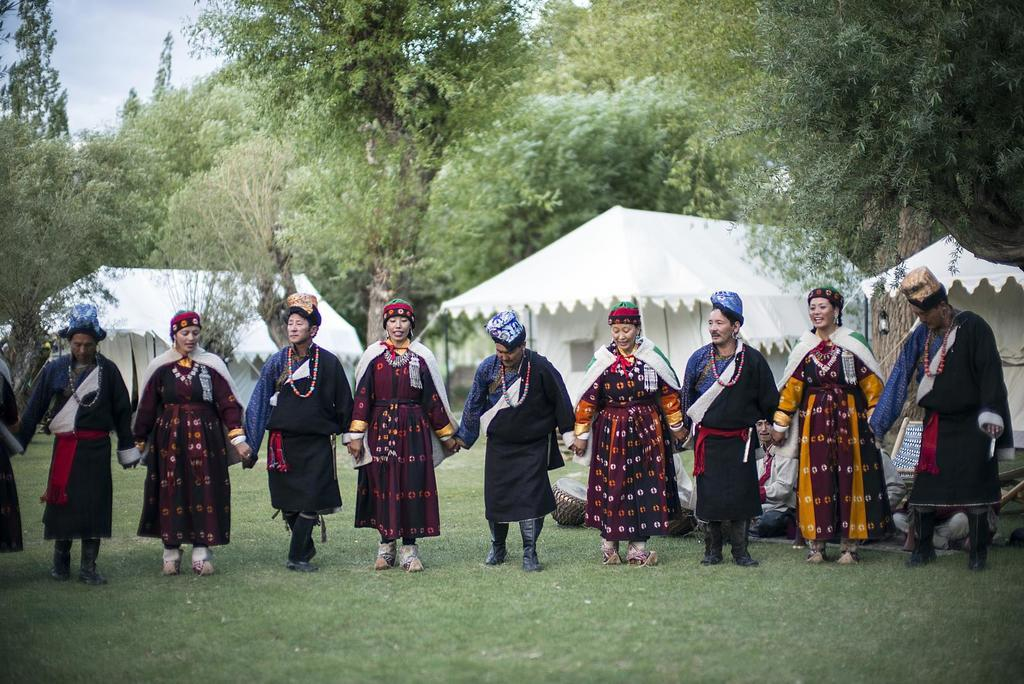What are the people in the image doing? The people in the image are standing and holding hands. Can you describe the background of the image? There is a tent and trees in the background of the image. What type of glue is being used to hold the lumber together in the image? There is no glue or lumber present in the image; it features people standing and holding hands with a tent and trees in the background. 